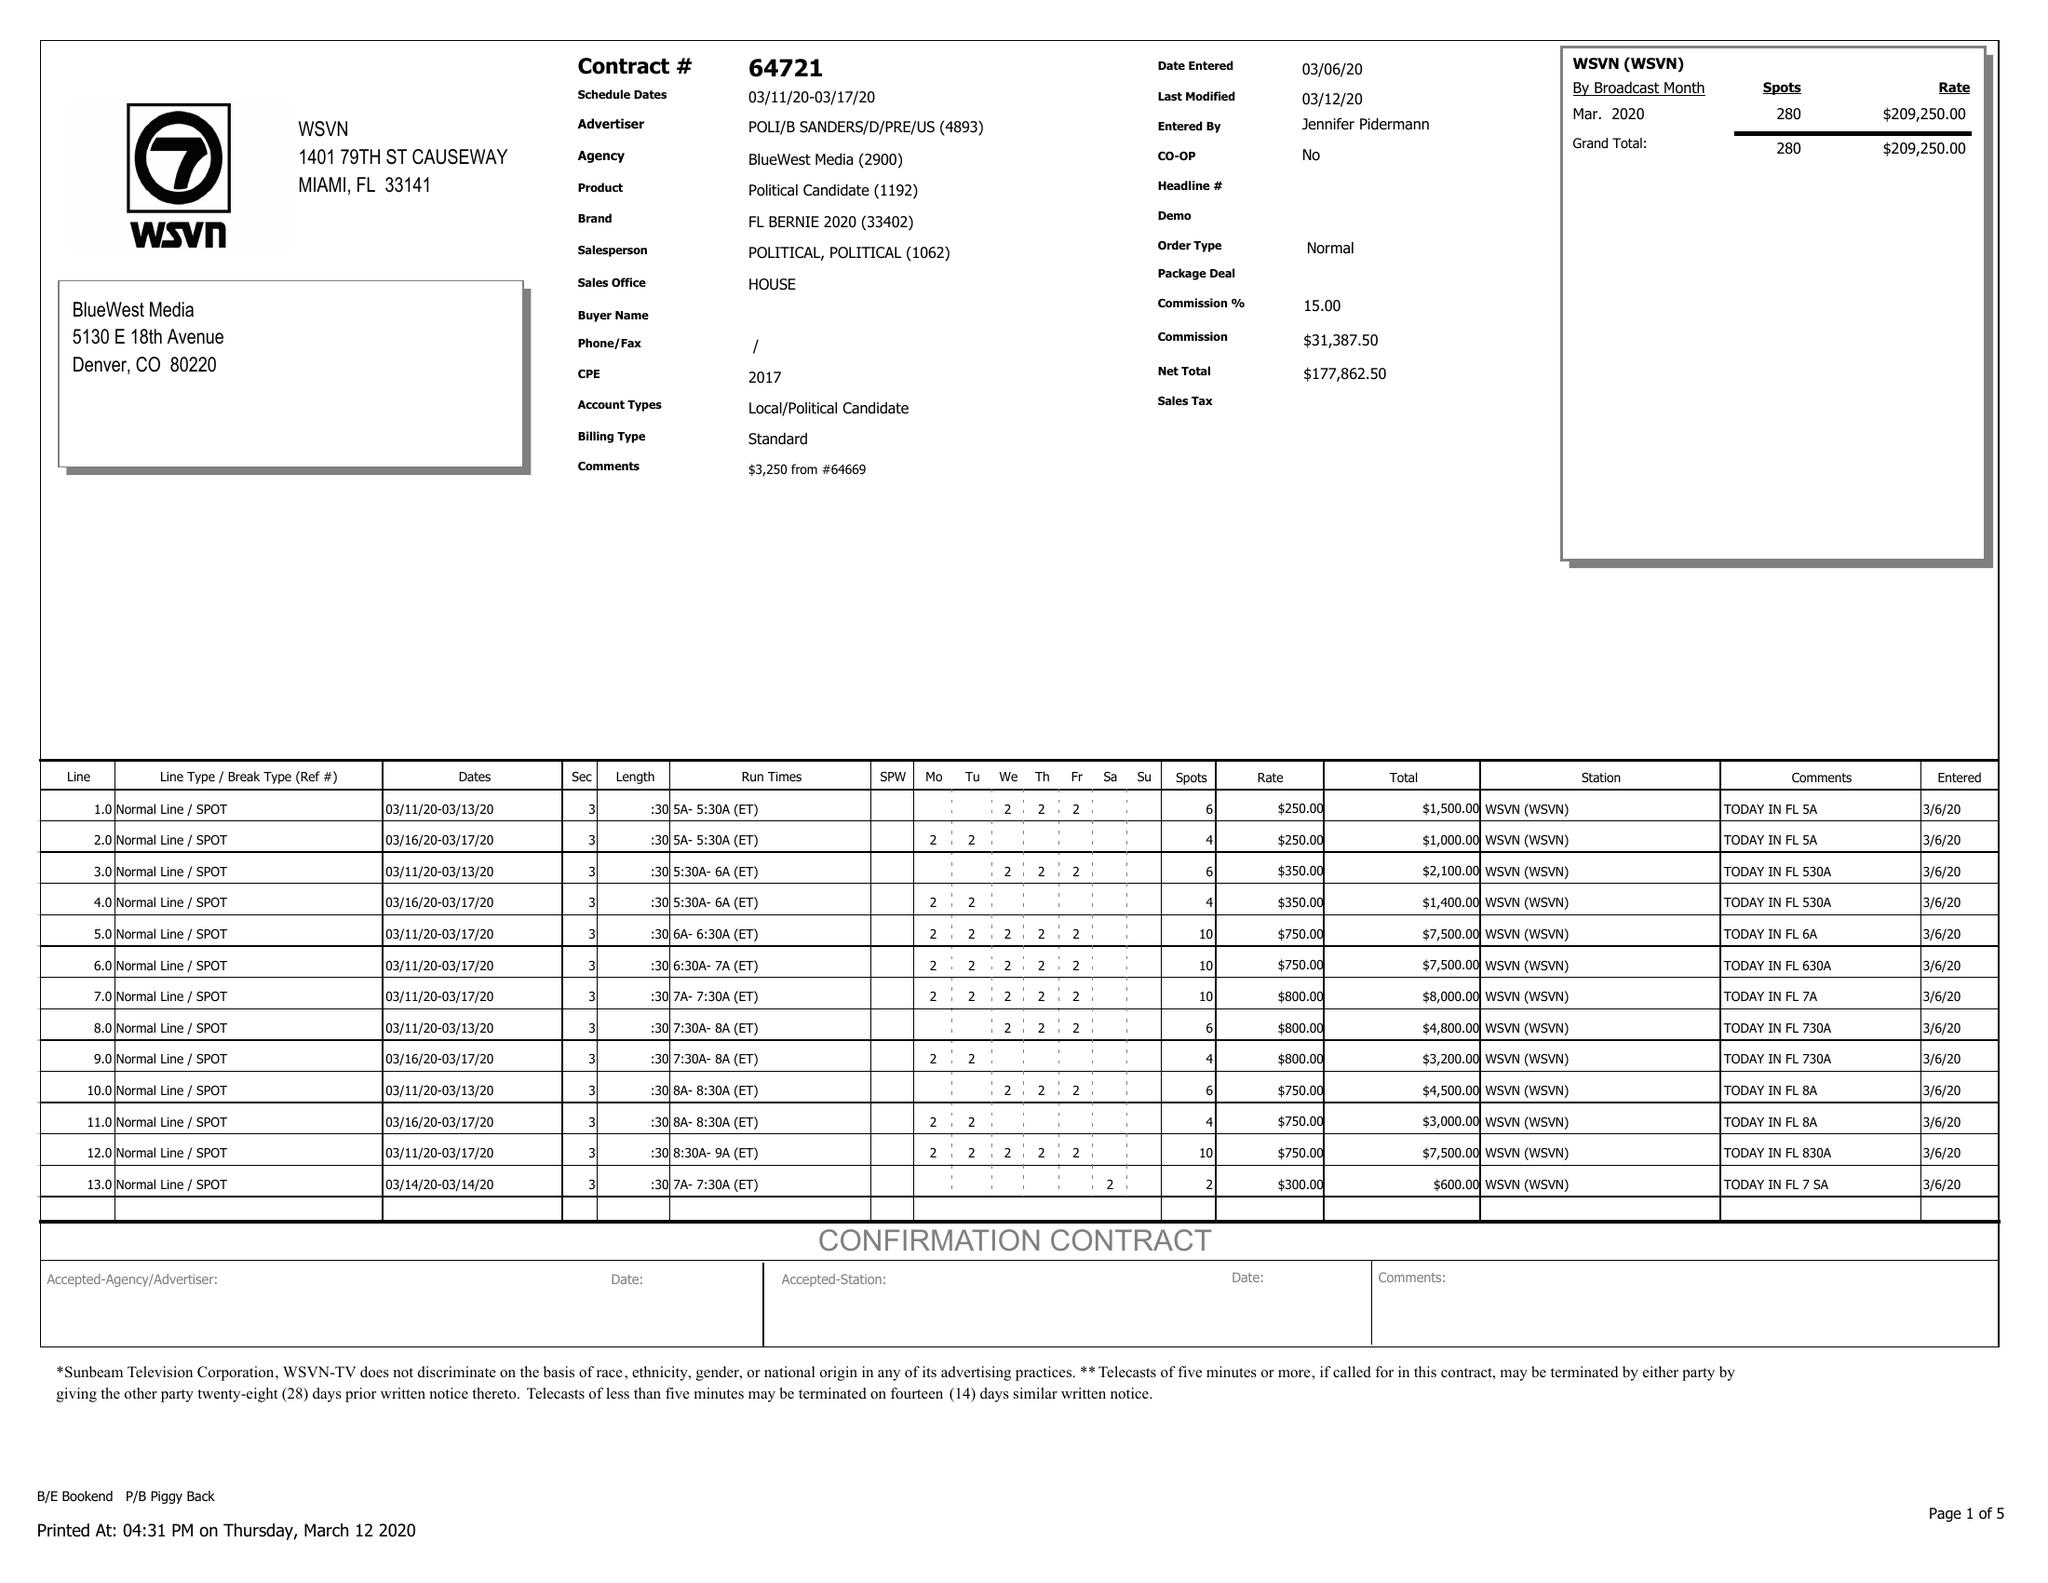What is the value for the advertiser?
Answer the question using a single word or phrase. POLI/BSANDERS/D/PRE/US 